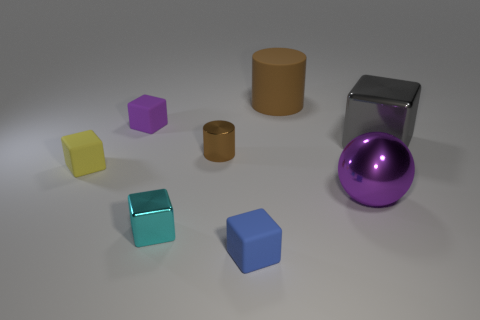How many brown metallic cylinders are there?
Ensure brevity in your answer.  1. What number of objects are both in front of the gray object and behind the tiny blue block?
Your answer should be very brief. 4. Are there any other things that have the same shape as the big purple thing?
Make the answer very short. No. Is the color of the tiny metallic cylinder the same as the cylinder that is behind the small brown shiny object?
Your answer should be very brief. Yes. The blue matte object that is left of the large cylinder has what shape?
Your answer should be compact. Cube. What is the material of the gray object?
Offer a terse response. Metal. What number of large objects are purple matte cubes or cyan blocks?
Your response must be concise. 0. There is a yellow object; how many brown metal objects are on the left side of it?
Your response must be concise. 0. Are there any big rubber things of the same color as the metallic cylinder?
Provide a short and direct response. Yes. What is the shape of the blue thing that is the same size as the yellow block?
Give a very brief answer. Cube. 